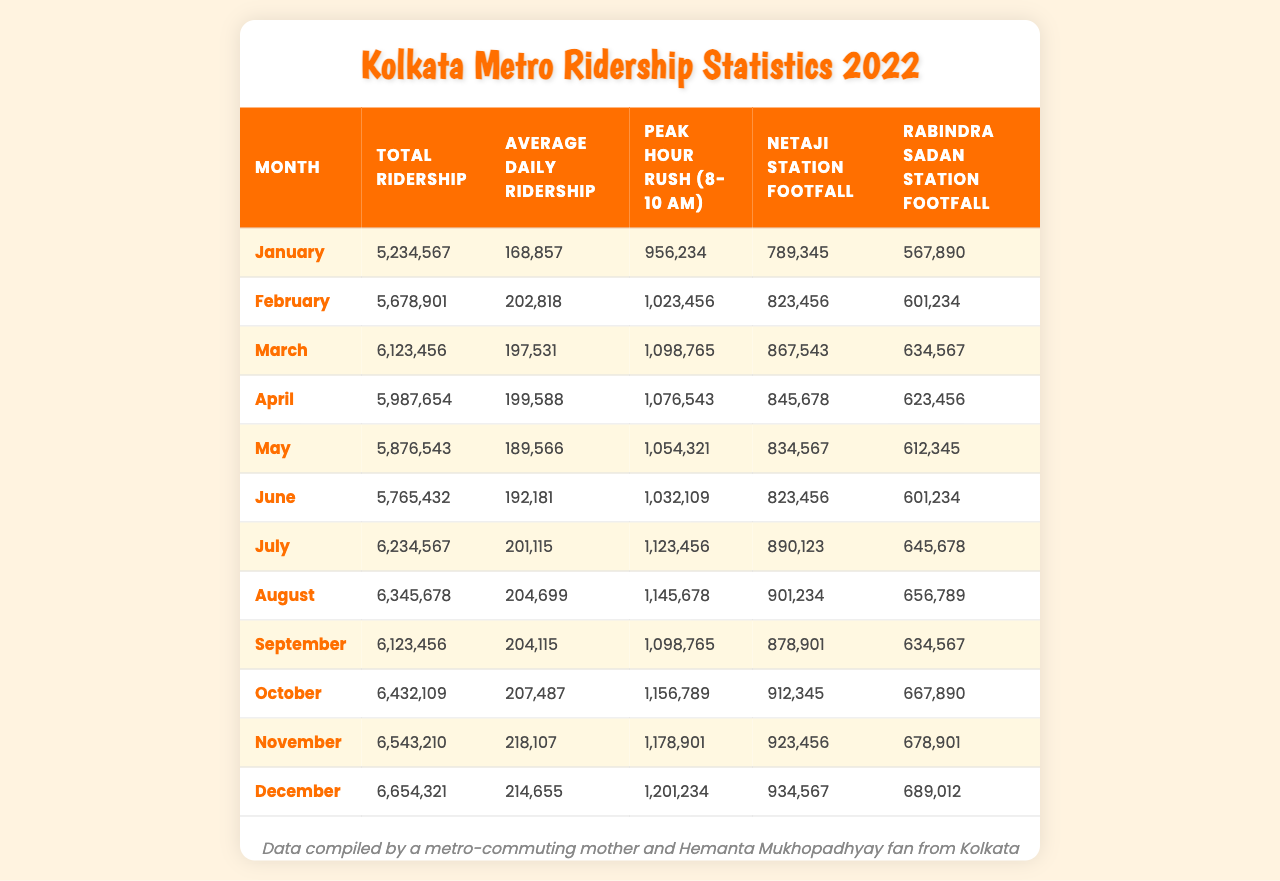What was the total ridership in December 2022? The table shows the total ridership for December is 6,654,321.
Answer: 6,654,321 Which month had the highest average daily ridership? By checking the Average Daily Ridership column, November has the highest value of 218,107.
Answer: November What is the total ridership for the first half of 2022 (January to June)? Adding the total ridership from January (5,234,567), February (5,678,901), March (6,123,456), April (5,987,654), May (5,876,543), and June (5,765,432) gives us 35,666,553.
Answer: 35,666,553 Did Netaji Station's footfall exceed 900,000 in any month? By examining the footfall data, we see that only in July and August (890,123 and 901,234 respectively) did it get close, thus showing no month had footfall exceeding 900,000.
Answer: No How much higher was the Peak Hour Rush in November compared to January? Subtracting the Peak Hour Rush in January (956,234) from that in November (1,178,901) gives us 222,667, indicating a higher rush.
Answer: 222,667 What is the average footfall of Rabindra Sadan Station over the year? By summing the footfall for each month (567,890 + 601,234 + 634,567 + 623,456 + 612,345 + 601,234 + 645,678 + 656,789 + 634,567 + 667,890 + 678,901 + 689,012) and dividing by 12 results in an average of 638,457.
Answer: 638,457 Which month had the lowest total ridership? Looking at the Total Ridership column, January has the lowest total of 5,234,567.
Answer: January What was the net increase in total ridership from January to October 2022? Subtracting the total ridership in January (5,234,567) from October (6,432,109) results in an increase of 1,197,542.
Answer: 1,197,542 In which month was the footfall at Netaji Station the highest? The highest footfall for Netaji Station occurred in November with a total of 923,456.
Answer: November Was there any month where the total ridership was less than 5 million? The table shows that every month in 2022 has a total ridership exceeding 5 million.
Answer: No What is the difference between the average daily ridership in October and the average in April? The average daily ridership in October (207,487) minus that in April (199,588) equals 7,899, showing an increase.
Answer: 7,899 